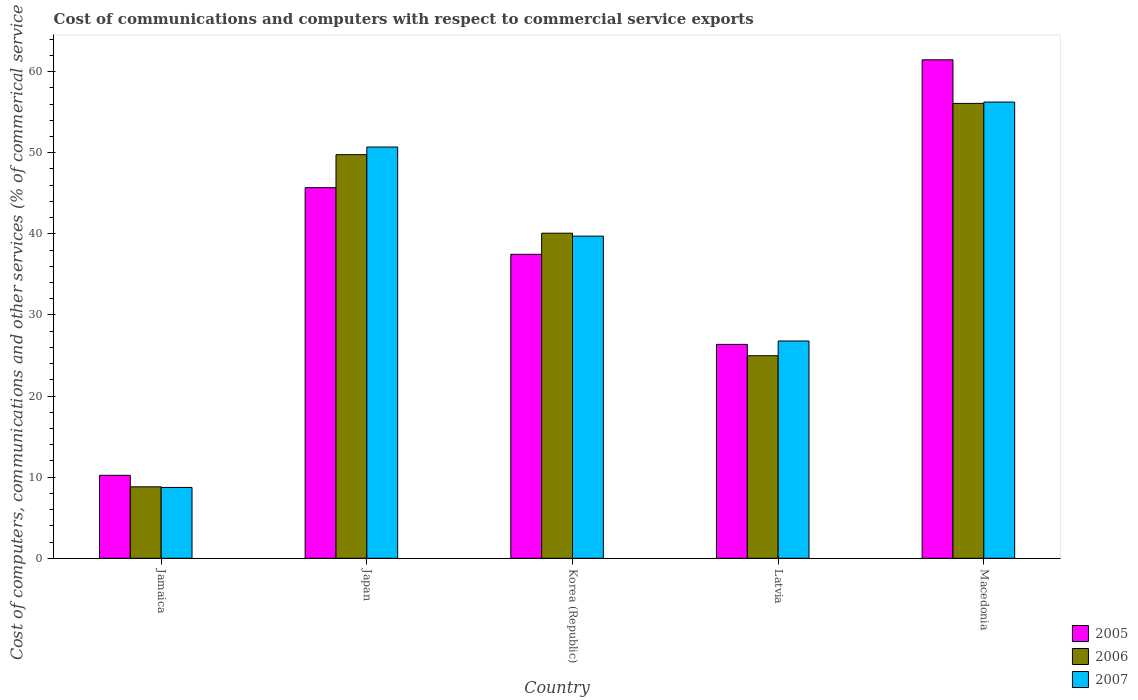How many groups of bars are there?
Provide a succinct answer. 5. What is the label of the 5th group of bars from the left?
Give a very brief answer. Macedonia. In how many cases, is the number of bars for a given country not equal to the number of legend labels?
Keep it short and to the point. 0. What is the cost of communications and computers in 2006 in Japan?
Your response must be concise. 49.77. Across all countries, what is the maximum cost of communications and computers in 2006?
Your answer should be compact. 56.09. Across all countries, what is the minimum cost of communications and computers in 2005?
Give a very brief answer. 10.23. In which country was the cost of communications and computers in 2007 maximum?
Make the answer very short. Macedonia. In which country was the cost of communications and computers in 2005 minimum?
Make the answer very short. Jamaica. What is the total cost of communications and computers in 2006 in the graph?
Give a very brief answer. 179.72. What is the difference between the cost of communications and computers in 2006 in Korea (Republic) and that in Latvia?
Give a very brief answer. 15.11. What is the difference between the cost of communications and computers in 2005 in Korea (Republic) and the cost of communications and computers in 2006 in Macedonia?
Your answer should be compact. -18.6. What is the average cost of communications and computers in 2007 per country?
Ensure brevity in your answer.  36.44. What is the difference between the cost of communications and computers of/in 2005 and cost of communications and computers of/in 2006 in Jamaica?
Give a very brief answer. 1.42. In how many countries, is the cost of communications and computers in 2006 greater than 22 %?
Make the answer very short. 4. What is the ratio of the cost of communications and computers in 2006 in Jamaica to that in Macedonia?
Make the answer very short. 0.16. Is the cost of communications and computers in 2006 in Korea (Republic) less than that in Macedonia?
Your response must be concise. Yes. Is the difference between the cost of communications and computers in 2005 in Latvia and Macedonia greater than the difference between the cost of communications and computers in 2006 in Latvia and Macedonia?
Your response must be concise. No. What is the difference between the highest and the second highest cost of communications and computers in 2005?
Offer a very short reply. -8.22. What is the difference between the highest and the lowest cost of communications and computers in 2007?
Ensure brevity in your answer.  47.52. In how many countries, is the cost of communications and computers in 2007 greater than the average cost of communications and computers in 2007 taken over all countries?
Your answer should be compact. 3. What does the 3rd bar from the right in Latvia represents?
Make the answer very short. 2005. Is it the case that in every country, the sum of the cost of communications and computers in 2006 and cost of communications and computers in 2005 is greater than the cost of communications and computers in 2007?
Keep it short and to the point. Yes. How many countries are there in the graph?
Your answer should be compact. 5. Does the graph contain grids?
Your answer should be compact. No. Where does the legend appear in the graph?
Make the answer very short. Bottom right. How are the legend labels stacked?
Your answer should be very brief. Vertical. What is the title of the graph?
Your answer should be very brief. Cost of communications and computers with respect to commercial service exports. Does "2001" appear as one of the legend labels in the graph?
Offer a very short reply. No. What is the label or title of the X-axis?
Make the answer very short. Country. What is the label or title of the Y-axis?
Offer a very short reply. Cost of computers, communications and other services (% of commerical service exports). What is the Cost of computers, communications and other services (% of commerical service exports) in 2005 in Jamaica?
Offer a very short reply. 10.23. What is the Cost of computers, communications and other services (% of commerical service exports) of 2006 in Jamaica?
Give a very brief answer. 8.81. What is the Cost of computers, communications and other services (% of commerical service exports) in 2007 in Jamaica?
Your response must be concise. 8.73. What is the Cost of computers, communications and other services (% of commerical service exports) in 2005 in Japan?
Your answer should be very brief. 45.7. What is the Cost of computers, communications and other services (% of commerical service exports) in 2006 in Japan?
Your answer should be compact. 49.77. What is the Cost of computers, communications and other services (% of commerical service exports) in 2007 in Japan?
Give a very brief answer. 50.71. What is the Cost of computers, communications and other services (% of commerical service exports) in 2005 in Korea (Republic)?
Give a very brief answer. 37.48. What is the Cost of computers, communications and other services (% of commerical service exports) of 2006 in Korea (Republic)?
Ensure brevity in your answer.  40.08. What is the Cost of computers, communications and other services (% of commerical service exports) in 2007 in Korea (Republic)?
Your answer should be very brief. 39.72. What is the Cost of computers, communications and other services (% of commerical service exports) in 2005 in Latvia?
Give a very brief answer. 26.37. What is the Cost of computers, communications and other services (% of commerical service exports) of 2006 in Latvia?
Provide a succinct answer. 24.97. What is the Cost of computers, communications and other services (% of commerical service exports) of 2007 in Latvia?
Keep it short and to the point. 26.79. What is the Cost of computers, communications and other services (% of commerical service exports) in 2005 in Macedonia?
Your answer should be very brief. 61.46. What is the Cost of computers, communications and other services (% of commerical service exports) of 2006 in Macedonia?
Ensure brevity in your answer.  56.09. What is the Cost of computers, communications and other services (% of commerical service exports) of 2007 in Macedonia?
Offer a terse response. 56.25. Across all countries, what is the maximum Cost of computers, communications and other services (% of commerical service exports) in 2005?
Ensure brevity in your answer.  61.46. Across all countries, what is the maximum Cost of computers, communications and other services (% of commerical service exports) in 2006?
Offer a very short reply. 56.09. Across all countries, what is the maximum Cost of computers, communications and other services (% of commerical service exports) in 2007?
Your answer should be compact. 56.25. Across all countries, what is the minimum Cost of computers, communications and other services (% of commerical service exports) of 2005?
Keep it short and to the point. 10.23. Across all countries, what is the minimum Cost of computers, communications and other services (% of commerical service exports) in 2006?
Make the answer very short. 8.81. Across all countries, what is the minimum Cost of computers, communications and other services (% of commerical service exports) of 2007?
Make the answer very short. 8.73. What is the total Cost of computers, communications and other services (% of commerical service exports) of 2005 in the graph?
Provide a succinct answer. 181.24. What is the total Cost of computers, communications and other services (% of commerical service exports) of 2006 in the graph?
Provide a short and direct response. 179.72. What is the total Cost of computers, communications and other services (% of commerical service exports) of 2007 in the graph?
Provide a succinct answer. 182.2. What is the difference between the Cost of computers, communications and other services (% of commerical service exports) of 2005 in Jamaica and that in Japan?
Provide a succinct answer. -35.47. What is the difference between the Cost of computers, communications and other services (% of commerical service exports) of 2006 in Jamaica and that in Japan?
Offer a very short reply. -40.96. What is the difference between the Cost of computers, communications and other services (% of commerical service exports) in 2007 in Jamaica and that in Japan?
Your answer should be very brief. -41.97. What is the difference between the Cost of computers, communications and other services (% of commerical service exports) in 2005 in Jamaica and that in Korea (Republic)?
Your response must be concise. -27.25. What is the difference between the Cost of computers, communications and other services (% of commerical service exports) of 2006 in Jamaica and that in Korea (Republic)?
Keep it short and to the point. -31.27. What is the difference between the Cost of computers, communications and other services (% of commerical service exports) of 2007 in Jamaica and that in Korea (Republic)?
Your answer should be compact. -30.99. What is the difference between the Cost of computers, communications and other services (% of commerical service exports) of 2005 in Jamaica and that in Latvia?
Offer a terse response. -16.14. What is the difference between the Cost of computers, communications and other services (% of commerical service exports) in 2006 in Jamaica and that in Latvia?
Your answer should be compact. -16.16. What is the difference between the Cost of computers, communications and other services (% of commerical service exports) in 2007 in Jamaica and that in Latvia?
Offer a very short reply. -18.06. What is the difference between the Cost of computers, communications and other services (% of commerical service exports) of 2005 in Jamaica and that in Macedonia?
Give a very brief answer. -51.23. What is the difference between the Cost of computers, communications and other services (% of commerical service exports) in 2006 in Jamaica and that in Macedonia?
Offer a terse response. -47.28. What is the difference between the Cost of computers, communications and other services (% of commerical service exports) of 2007 in Jamaica and that in Macedonia?
Keep it short and to the point. -47.52. What is the difference between the Cost of computers, communications and other services (% of commerical service exports) of 2005 in Japan and that in Korea (Republic)?
Give a very brief answer. 8.22. What is the difference between the Cost of computers, communications and other services (% of commerical service exports) in 2006 in Japan and that in Korea (Republic)?
Provide a succinct answer. 9.68. What is the difference between the Cost of computers, communications and other services (% of commerical service exports) in 2007 in Japan and that in Korea (Republic)?
Ensure brevity in your answer.  10.99. What is the difference between the Cost of computers, communications and other services (% of commerical service exports) in 2005 in Japan and that in Latvia?
Provide a succinct answer. 19.33. What is the difference between the Cost of computers, communications and other services (% of commerical service exports) of 2006 in Japan and that in Latvia?
Provide a succinct answer. 24.79. What is the difference between the Cost of computers, communications and other services (% of commerical service exports) in 2007 in Japan and that in Latvia?
Keep it short and to the point. 23.92. What is the difference between the Cost of computers, communications and other services (% of commerical service exports) in 2005 in Japan and that in Macedonia?
Provide a short and direct response. -15.77. What is the difference between the Cost of computers, communications and other services (% of commerical service exports) of 2006 in Japan and that in Macedonia?
Offer a terse response. -6.32. What is the difference between the Cost of computers, communications and other services (% of commerical service exports) in 2007 in Japan and that in Macedonia?
Your response must be concise. -5.54. What is the difference between the Cost of computers, communications and other services (% of commerical service exports) of 2005 in Korea (Republic) and that in Latvia?
Make the answer very short. 11.11. What is the difference between the Cost of computers, communications and other services (% of commerical service exports) in 2006 in Korea (Republic) and that in Latvia?
Keep it short and to the point. 15.11. What is the difference between the Cost of computers, communications and other services (% of commerical service exports) of 2007 in Korea (Republic) and that in Latvia?
Your response must be concise. 12.93. What is the difference between the Cost of computers, communications and other services (% of commerical service exports) in 2005 in Korea (Republic) and that in Macedonia?
Your answer should be very brief. -23.98. What is the difference between the Cost of computers, communications and other services (% of commerical service exports) of 2006 in Korea (Republic) and that in Macedonia?
Provide a short and direct response. -16. What is the difference between the Cost of computers, communications and other services (% of commerical service exports) of 2007 in Korea (Republic) and that in Macedonia?
Make the answer very short. -16.53. What is the difference between the Cost of computers, communications and other services (% of commerical service exports) of 2005 in Latvia and that in Macedonia?
Your answer should be compact. -35.09. What is the difference between the Cost of computers, communications and other services (% of commerical service exports) of 2006 in Latvia and that in Macedonia?
Provide a short and direct response. -31.11. What is the difference between the Cost of computers, communications and other services (% of commerical service exports) in 2007 in Latvia and that in Macedonia?
Keep it short and to the point. -29.46. What is the difference between the Cost of computers, communications and other services (% of commerical service exports) in 2005 in Jamaica and the Cost of computers, communications and other services (% of commerical service exports) in 2006 in Japan?
Your response must be concise. -39.54. What is the difference between the Cost of computers, communications and other services (% of commerical service exports) in 2005 in Jamaica and the Cost of computers, communications and other services (% of commerical service exports) in 2007 in Japan?
Your response must be concise. -40.48. What is the difference between the Cost of computers, communications and other services (% of commerical service exports) in 2006 in Jamaica and the Cost of computers, communications and other services (% of commerical service exports) in 2007 in Japan?
Keep it short and to the point. -41.9. What is the difference between the Cost of computers, communications and other services (% of commerical service exports) in 2005 in Jamaica and the Cost of computers, communications and other services (% of commerical service exports) in 2006 in Korea (Republic)?
Make the answer very short. -29.85. What is the difference between the Cost of computers, communications and other services (% of commerical service exports) of 2005 in Jamaica and the Cost of computers, communications and other services (% of commerical service exports) of 2007 in Korea (Republic)?
Offer a terse response. -29.49. What is the difference between the Cost of computers, communications and other services (% of commerical service exports) in 2006 in Jamaica and the Cost of computers, communications and other services (% of commerical service exports) in 2007 in Korea (Republic)?
Offer a very short reply. -30.91. What is the difference between the Cost of computers, communications and other services (% of commerical service exports) of 2005 in Jamaica and the Cost of computers, communications and other services (% of commerical service exports) of 2006 in Latvia?
Provide a succinct answer. -14.74. What is the difference between the Cost of computers, communications and other services (% of commerical service exports) in 2005 in Jamaica and the Cost of computers, communications and other services (% of commerical service exports) in 2007 in Latvia?
Provide a succinct answer. -16.56. What is the difference between the Cost of computers, communications and other services (% of commerical service exports) in 2006 in Jamaica and the Cost of computers, communications and other services (% of commerical service exports) in 2007 in Latvia?
Offer a very short reply. -17.98. What is the difference between the Cost of computers, communications and other services (% of commerical service exports) of 2005 in Jamaica and the Cost of computers, communications and other services (% of commerical service exports) of 2006 in Macedonia?
Your answer should be compact. -45.86. What is the difference between the Cost of computers, communications and other services (% of commerical service exports) in 2005 in Jamaica and the Cost of computers, communications and other services (% of commerical service exports) in 2007 in Macedonia?
Offer a very short reply. -46.02. What is the difference between the Cost of computers, communications and other services (% of commerical service exports) of 2006 in Jamaica and the Cost of computers, communications and other services (% of commerical service exports) of 2007 in Macedonia?
Offer a very short reply. -47.44. What is the difference between the Cost of computers, communications and other services (% of commerical service exports) of 2005 in Japan and the Cost of computers, communications and other services (% of commerical service exports) of 2006 in Korea (Republic)?
Keep it short and to the point. 5.62. What is the difference between the Cost of computers, communications and other services (% of commerical service exports) of 2005 in Japan and the Cost of computers, communications and other services (% of commerical service exports) of 2007 in Korea (Republic)?
Ensure brevity in your answer.  5.98. What is the difference between the Cost of computers, communications and other services (% of commerical service exports) of 2006 in Japan and the Cost of computers, communications and other services (% of commerical service exports) of 2007 in Korea (Republic)?
Your response must be concise. 10.05. What is the difference between the Cost of computers, communications and other services (% of commerical service exports) of 2005 in Japan and the Cost of computers, communications and other services (% of commerical service exports) of 2006 in Latvia?
Offer a very short reply. 20.72. What is the difference between the Cost of computers, communications and other services (% of commerical service exports) of 2005 in Japan and the Cost of computers, communications and other services (% of commerical service exports) of 2007 in Latvia?
Your answer should be compact. 18.91. What is the difference between the Cost of computers, communications and other services (% of commerical service exports) of 2006 in Japan and the Cost of computers, communications and other services (% of commerical service exports) of 2007 in Latvia?
Your response must be concise. 22.97. What is the difference between the Cost of computers, communications and other services (% of commerical service exports) of 2005 in Japan and the Cost of computers, communications and other services (% of commerical service exports) of 2006 in Macedonia?
Offer a terse response. -10.39. What is the difference between the Cost of computers, communications and other services (% of commerical service exports) of 2005 in Japan and the Cost of computers, communications and other services (% of commerical service exports) of 2007 in Macedonia?
Keep it short and to the point. -10.55. What is the difference between the Cost of computers, communications and other services (% of commerical service exports) in 2006 in Japan and the Cost of computers, communications and other services (% of commerical service exports) in 2007 in Macedonia?
Offer a very short reply. -6.49. What is the difference between the Cost of computers, communications and other services (% of commerical service exports) of 2005 in Korea (Republic) and the Cost of computers, communications and other services (% of commerical service exports) of 2006 in Latvia?
Offer a terse response. 12.51. What is the difference between the Cost of computers, communications and other services (% of commerical service exports) in 2005 in Korea (Republic) and the Cost of computers, communications and other services (% of commerical service exports) in 2007 in Latvia?
Provide a short and direct response. 10.69. What is the difference between the Cost of computers, communications and other services (% of commerical service exports) of 2006 in Korea (Republic) and the Cost of computers, communications and other services (% of commerical service exports) of 2007 in Latvia?
Give a very brief answer. 13.29. What is the difference between the Cost of computers, communications and other services (% of commerical service exports) in 2005 in Korea (Republic) and the Cost of computers, communications and other services (% of commerical service exports) in 2006 in Macedonia?
Ensure brevity in your answer.  -18.6. What is the difference between the Cost of computers, communications and other services (% of commerical service exports) of 2005 in Korea (Republic) and the Cost of computers, communications and other services (% of commerical service exports) of 2007 in Macedonia?
Provide a succinct answer. -18.77. What is the difference between the Cost of computers, communications and other services (% of commerical service exports) in 2006 in Korea (Republic) and the Cost of computers, communications and other services (% of commerical service exports) in 2007 in Macedonia?
Offer a very short reply. -16.17. What is the difference between the Cost of computers, communications and other services (% of commerical service exports) in 2005 in Latvia and the Cost of computers, communications and other services (% of commerical service exports) in 2006 in Macedonia?
Your answer should be compact. -29.71. What is the difference between the Cost of computers, communications and other services (% of commerical service exports) of 2005 in Latvia and the Cost of computers, communications and other services (% of commerical service exports) of 2007 in Macedonia?
Provide a short and direct response. -29.88. What is the difference between the Cost of computers, communications and other services (% of commerical service exports) of 2006 in Latvia and the Cost of computers, communications and other services (% of commerical service exports) of 2007 in Macedonia?
Provide a succinct answer. -31.28. What is the average Cost of computers, communications and other services (% of commerical service exports) in 2005 per country?
Keep it short and to the point. 36.25. What is the average Cost of computers, communications and other services (% of commerical service exports) of 2006 per country?
Keep it short and to the point. 35.94. What is the average Cost of computers, communications and other services (% of commerical service exports) in 2007 per country?
Keep it short and to the point. 36.44. What is the difference between the Cost of computers, communications and other services (% of commerical service exports) in 2005 and Cost of computers, communications and other services (% of commerical service exports) in 2006 in Jamaica?
Your response must be concise. 1.42. What is the difference between the Cost of computers, communications and other services (% of commerical service exports) of 2005 and Cost of computers, communications and other services (% of commerical service exports) of 2007 in Jamaica?
Your answer should be compact. 1.49. What is the difference between the Cost of computers, communications and other services (% of commerical service exports) of 2006 and Cost of computers, communications and other services (% of commerical service exports) of 2007 in Jamaica?
Give a very brief answer. 0.08. What is the difference between the Cost of computers, communications and other services (% of commerical service exports) of 2005 and Cost of computers, communications and other services (% of commerical service exports) of 2006 in Japan?
Keep it short and to the point. -4.07. What is the difference between the Cost of computers, communications and other services (% of commerical service exports) in 2005 and Cost of computers, communications and other services (% of commerical service exports) in 2007 in Japan?
Your answer should be compact. -5.01. What is the difference between the Cost of computers, communications and other services (% of commerical service exports) of 2006 and Cost of computers, communications and other services (% of commerical service exports) of 2007 in Japan?
Provide a succinct answer. -0.94. What is the difference between the Cost of computers, communications and other services (% of commerical service exports) of 2005 and Cost of computers, communications and other services (% of commerical service exports) of 2006 in Korea (Republic)?
Make the answer very short. -2.6. What is the difference between the Cost of computers, communications and other services (% of commerical service exports) of 2005 and Cost of computers, communications and other services (% of commerical service exports) of 2007 in Korea (Republic)?
Your answer should be very brief. -2.24. What is the difference between the Cost of computers, communications and other services (% of commerical service exports) of 2006 and Cost of computers, communications and other services (% of commerical service exports) of 2007 in Korea (Republic)?
Give a very brief answer. 0.36. What is the difference between the Cost of computers, communications and other services (% of commerical service exports) of 2005 and Cost of computers, communications and other services (% of commerical service exports) of 2006 in Latvia?
Make the answer very short. 1.4. What is the difference between the Cost of computers, communications and other services (% of commerical service exports) of 2005 and Cost of computers, communications and other services (% of commerical service exports) of 2007 in Latvia?
Give a very brief answer. -0.42. What is the difference between the Cost of computers, communications and other services (% of commerical service exports) of 2006 and Cost of computers, communications and other services (% of commerical service exports) of 2007 in Latvia?
Your answer should be very brief. -1.82. What is the difference between the Cost of computers, communications and other services (% of commerical service exports) in 2005 and Cost of computers, communications and other services (% of commerical service exports) in 2006 in Macedonia?
Your answer should be compact. 5.38. What is the difference between the Cost of computers, communications and other services (% of commerical service exports) in 2005 and Cost of computers, communications and other services (% of commerical service exports) in 2007 in Macedonia?
Offer a very short reply. 5.21. What is the difference between the Cost of computers, communications and other services (% of commerical service exports) in 2006 and Cost of computers, communications and other services (% of commerical service exports) in 2007 in Macedonia?
Offer a terse response. -0.17. What is the ratio of the Cost of computers, communications and other services (% of commerical service exports) of 2005 in Jamaica to that in Japan?
Your answer should be compact. 0.22. What is the ratio of the Cost of computers, communications and other services (% of commerical service exports) in 2006 in Jamaica to that in Japan?
Offer a very short reply. 0.18. What is the ratio of the Cost of computers, communications and other services (% of commerical service exports) in 2007 in Jamaica to that in Japan?
Your answer should be very brief. 0.17. What is the ratio of the Cost of computers, communications and other services (% of commerical service exports) of 2005 in Jamaica to that in Korea (Republic)?
Give a very brief answer. 0.27. What is the ratio of the Cost of computers, communications and other services (% of commerical service exports) of 2006 in Jamaica to that in Korea (Republic)?
Ensure brevity in your answer.  0.22. What is the ratio of the Cost of computers, communications and other services (% of commerical service exports) in 2007 in Jamaica to that in Korea (Republic)?
Keep it short and to the point. 0.22. What is the ratio of the Cost of computers, communications and other services (% of commerical service exports) of 2005 in Jamaica to that in Latvia?
Keep it short and to the point. 0.39. What is the ratio of the Cost of computers, communications and other services (% of commerical service exports) in 2006 in Jamaica to that in Latvia?
Provide a succinct answer. 0.35. What is the ratio of the Cost of computers, communications and other services (% of commerical service exports) of 2007 in Jamaica to that in Latvia?
Keep it short and to the point. 0.33. What is the ratio of the Cost of computers, communications and other services (% of commerical service exports) in 2005 in Jamaica to that in Macedonia?
Offer a terse response. 0.17. What is the ratio of the Cost of computers, communications and other services (% of commerical service exports) of 2006 in Jamaica to that in Macedonia?
Offer a terse response. 0.16. What is the ratio of the Cost of computers, communications and other services (% of commerical service exports) of 2007 in Jamaica to that in Macedonia?
Offer a terse response. 0.16. What is the ratio of the Cost of computers, communications and other services (% of commerical service exports) in 2005 in Japan to that in Korea (Republic)?
Your answer should be compact. 1.22. What is the ratio of the Cost of computers, communications and other services (% of commerical service exports) of 2006 in Japan to that in Korea (Republic)?
Your answer should be very brief. 1.24. What is the ratio of the Cost of computers, communications and other services (% of commerical service exports) in 2007 in Japan to that in Korea (Republic)?
Offer a terse response. 1.28. What is the ratio of the Cost of computers, communications and other services (% of commerical service exports) of 2005 in Japan to that in Latvia?
Provide a succinct answer. 1.73. What is the ratio of the Cost of computers, communications and other services (% of commerical service exports) of 2006 in Japan to that in Latvia?
Your answer should be very brief. 1.99. What is the ratio of the Cost of computers, communications and other services (% of commerical service exports) of 2007 in Japan to that in Latvia?
Ensure brevity in your answer.  1.89. What is the ratio of the Cost of computers, communications and other services (% of commerical service exports) of 2005 in Japan to that in Macedonia?
Offer a very short reply. 0.74. What is the ratio of the Cost of computers, communications and other services (% of commerical service exports) of 2006 in Japan to that in Macedonia?
Make the answer very short. 0.89. What is the ratio of the Cost of computers, communications and other services (% of commerical service exports) in 2007 in Japan to that in Macedonia?
Offer a terse response. 0.9. What is the ratio of the Cost of computers, communications and other services (% of commerical service exports) of 2005 in Korea (Republic) to that in Latvia?
Offer a very short reply. 1.42. What is the ratio of the Cost of computers, communications and other services (% of commerical service exports) in 2006 in Korea (Republic) to that in Latvia?
Your response must be concise. 1.6. What is the ratio of the Cost of computers, communications and other services (% of commerical service exports) in 2007 in Korea (Republic) to that in Latvia?
Offer a very short reply. 1.48. What is the ratio of the Cost of computers, communications and other services (% of commerical service exports) in 2005 in Korea (Republic) to that in Macedonia?
Your answer should be compact. 0.61. What is the ratio of the Cost of computers, communications and other services (% of commerical service exports) in 2006 in Korea (Republic) to that in Macedonia?
Offer a very short reply. 0.71. What is the ratio of the Cost of computers, communications and other services (% of commerical service exports) of 2007 in Korea (Republic) to that in Macedonia?
Provide a succinct answer. 0.71. What is the ratio of the Cost of computers, communications and other services (% of commerical service exports) in 2005 in Latvia to that in Macedonia?
Your response must be concise. 0.43. What is the ratio of the Cost of computers, communications and other services (% of commerical service exports) in 2006 in Latvia to that in Macedonia?
Your answer should be very brief. 0.45. What is the ratio of the Cost of computers, communications and other services (% of commerical service exports) in 2007 in Latvia to that in Macedonia?
Offer a terse response. 0.48. What is the difference between the highest and the second highest Cost of computers, communications and other services (% of commerical service exports) in 2005?
Provide a short and direct response. 15.77. What is the difference between the highest and the second highest Cost of computers, communications and other services (% of commerical service exports) in 2006?
Your response must be concise. 6.32. What is the difference between the highest and the second highest Cost of computers, communications and other services (% of commerical service exports) of 2007?
Your answer should be compact. 5.54. What is the difference between the highest and the lowest Cost of computers, communications and other services (% of commerical service exports) of 2005?
Make the answer very short. 51.23. What is the difference between the highest and the lowest Cost of computers, communications and other services (% of commerical service exports) in 2006?
Your answer should be very brief. 47.28. What is the difference between the highest and the lowest Cost of computers, communications and other services (% of commerical service exports) of 2007?
Your answer should be very brief. 47.52. 